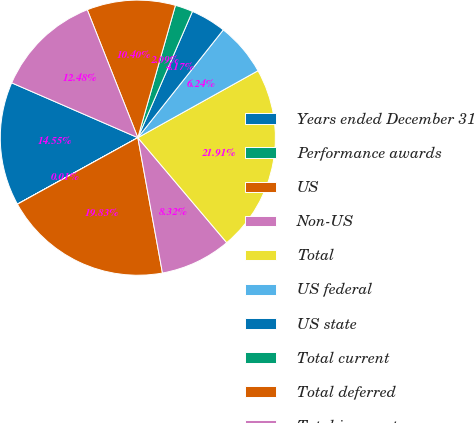Convert chart. <chart><loc_0><loc_0><loc_500><loc_500><pie_chart><fcel>Years ended December 31<fcel>Performance awards<fcel>US<fcel>Non-US<fcel>Total<fcel>US federal<fcel>US state<fcel>Total current<fcel>Total deferred<fcel>Total income tax expense<nl><fcel>14.55%<fcel>0.01%<fcel>19.83%<fcel>8.32%<fcel>21.91%<fcel>6.24%<fcel>4.17%<fcel>2.09%<fcel>10.4%<fcel>12.48%<nl></chart> 